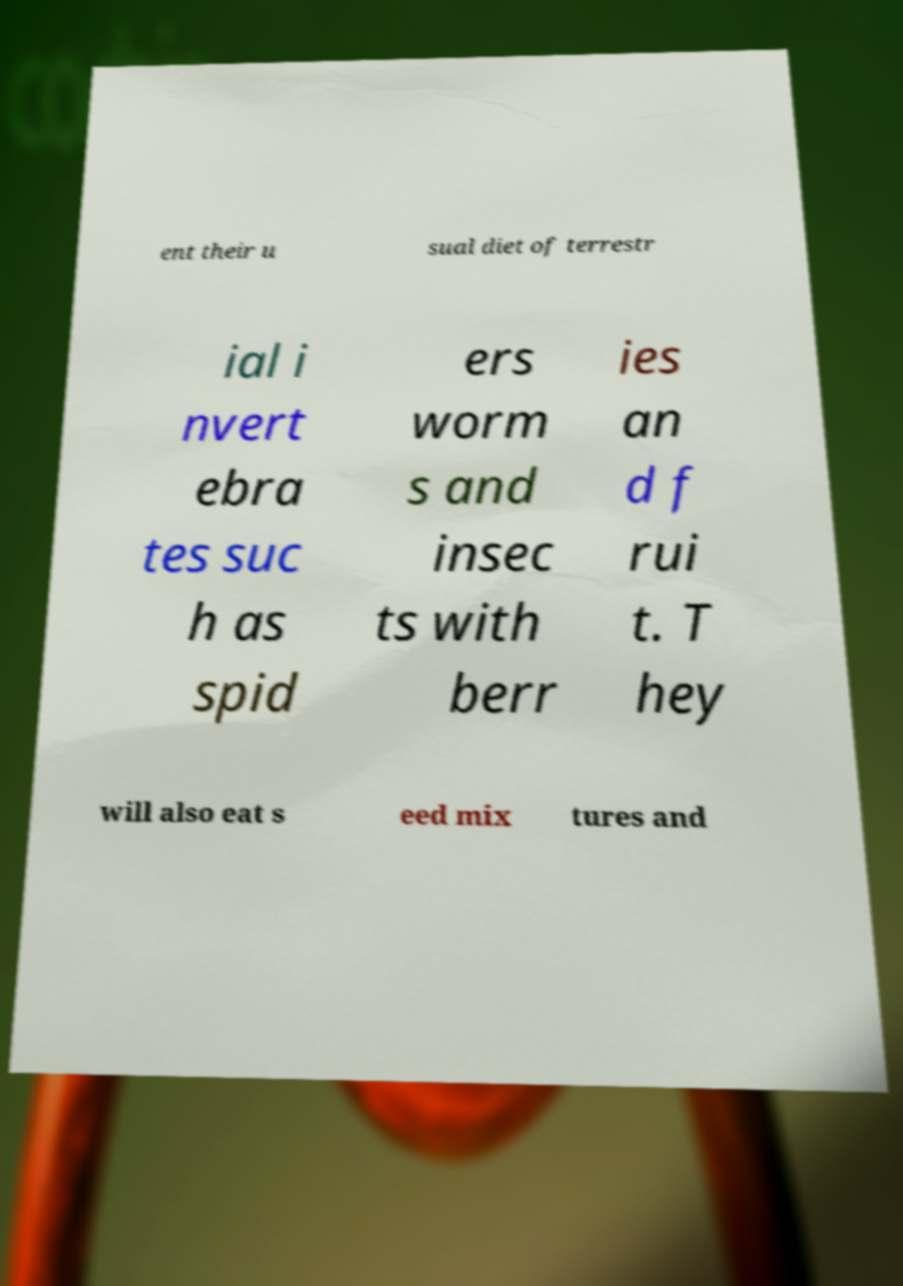Can you accurately transcribe the text from the provided image for me? ent their u sual diet of terrestr ial i nvert ebra tes suc h as spid ers worm s and insec ts with berr ies an d f rui t. T hey will also eat s eed mix tures and 